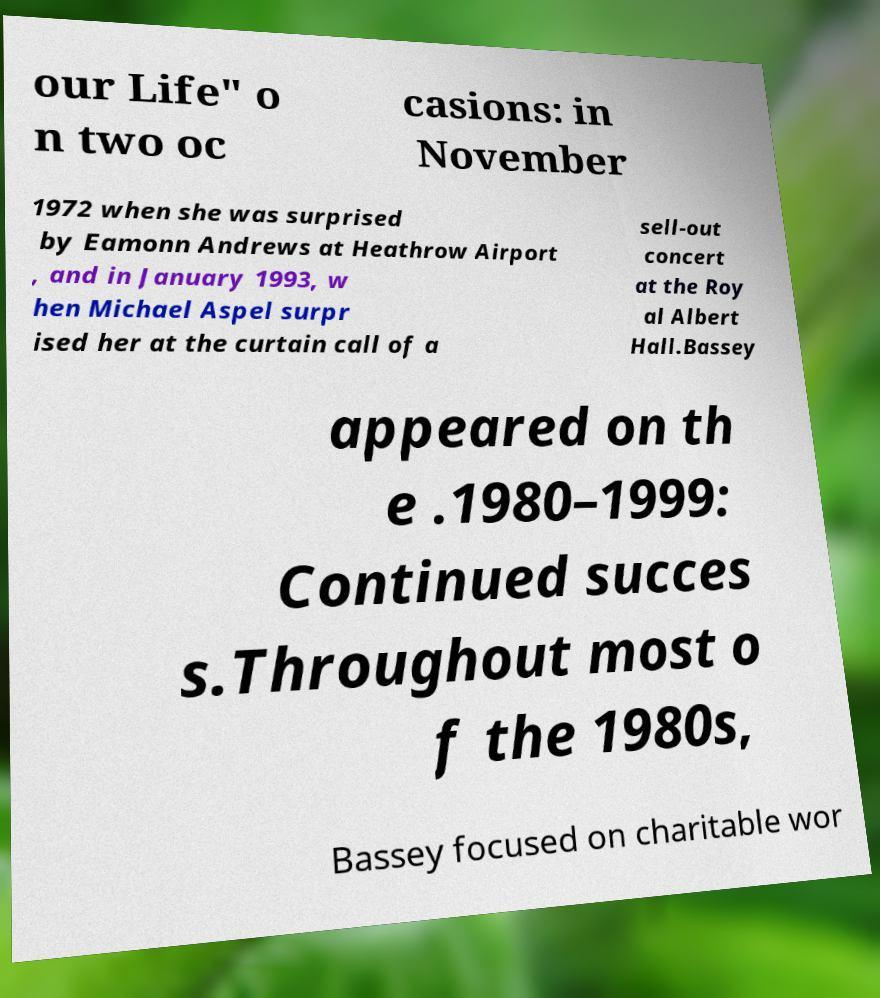Could you assist in decoding the text presented in this image and type it out clearly? our Life" o n two oc casions: in November 1972 when she was surprised by Eamonn Andrews at Heathrow Airport , and in January 1993, w hen Michael Aspel surpr ised her at the curtain call of a sell-out concert at the Roy al Albert Hall.Bassey appeared on th e .1980–1999: Continued succes s.Throughout most o f the 1980s, Bassey focused on charitable wor 